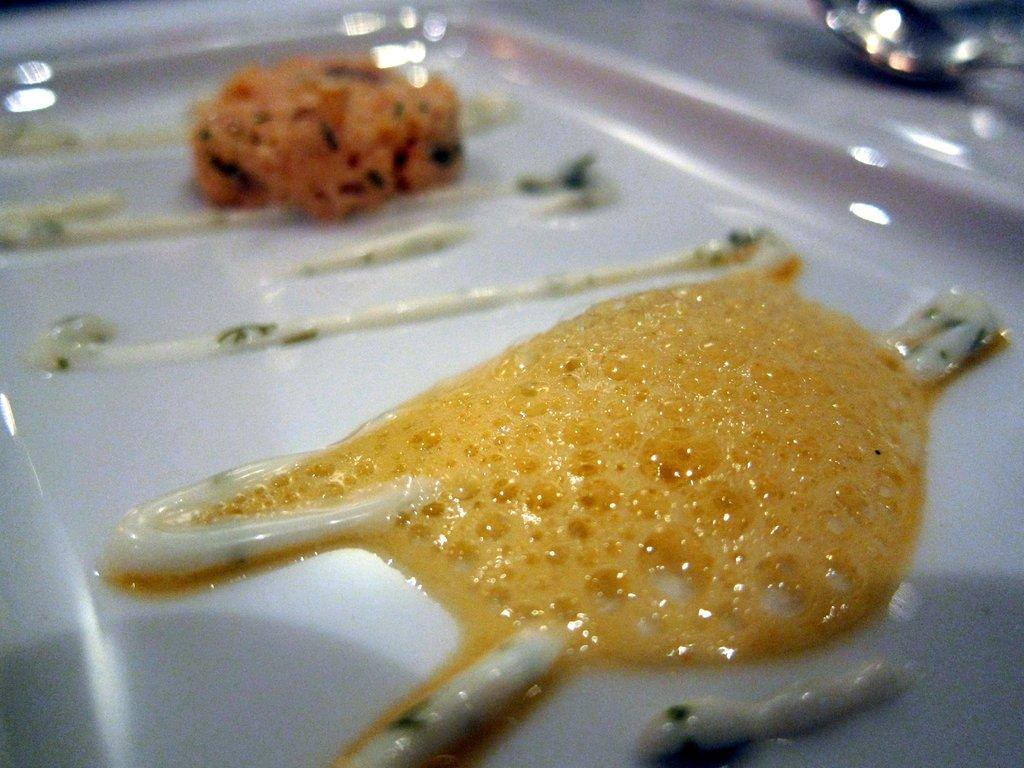What can be seen floating in the image? There are foam bubbles in the image. How would you describe the background of the image? The background of the image is blurred. What type of dish is present on a plate in the image? There is a food item on a plate in the image. What utensil is visible in the image? There is a spoon in the image. What type of quilt is being used to cover the kitten in the image? There is no quilt or kitten present in the image. What type of vegetable is being served on the plate in the image? The provided facts do not mention any specific food item on the plate, so we cannot determine if it is a vegetable or not. 